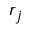Convert formula to latex. <formula><loc_0><loc_0><loc_500><loc_500>r _ { j }</formula> 